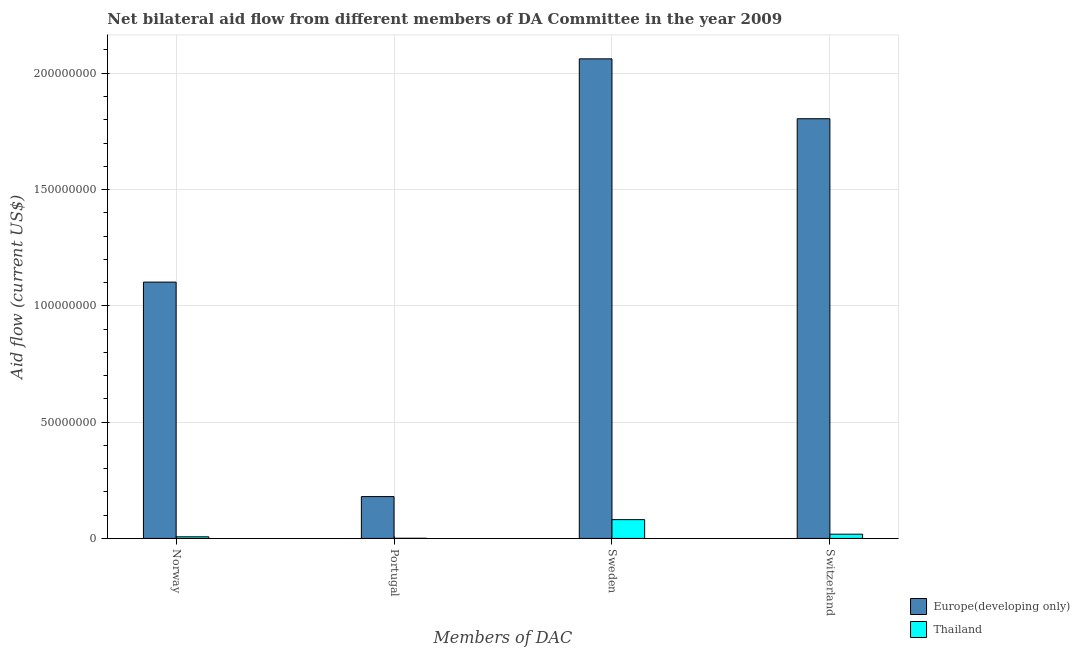Are the number of bars per tick equal to the number of legend labels?
Ensure brevity in your answer.  Yes. How many bars are there on the 4th tick from the left?
Your answer should be very brief. 2. How many bars are there on the 2nd tick from the right?
Your answer should be compact. 2. What is the amount of aid given by switzerland in Europe(developing only)?
Offer a very short reply. 1.80e+08. Across all countries, what is the maximum amount of aid given by portugal?
Ensure brevity in your answer.  1.80e+07. Across all countries, what is the minimum amount of aid given by switzerland?
Your answer should be very brief. 1.82e+06. In which country was the amount of aid given by portugal maximum?
Offer a terse response. Europe(developing only). In which country was the amount of aid given by sweden minimum?
Provide a succinct answer. Thailand. What is the total amount of aid given by sweden in the graph?
Provide a succinct answer. 2.14e+08. What is the difference between the amount of aid given by sweden in Thailand and that in Europe(developing only)?
Your response must be concise. -1.98e+08. What is the difference between the amount of aid given by portugal in Europe(developing only) and the amount of aid given by sweden in Thailand?
Make the answer very short. 9.91e+06. What is the average amount of aid given by switzerland per country?
Make the answer very short. 9.11e+07. What is the difference between the amount of aid given by switzerland and amount of aid given by portugal in Thailand?
Offer a terse response. 1.75e+06. In how many countries, is the amount of aid given by norway greater than 10000000 US$?
Offer a very short reply. 1. What is the ratio of the amount of aid given by switzerland in Thailand to that in Europe(developing only)?
Keep it short and to the point. 0.01. Is the difference between the amount of aid given by norway in Thailand and Europe(developing only) greater than the difference between the amount of aid given by switzerland in Thailand and Europe(developing only)?
Your response must be concise. Yes. What is the difference between the highest and the second highest amount of aid given by norway?
Make the answer very short. 1.10e+08. What is the difference between the highest and the lowest amount of aid given by switzerland?
Your answer should be very brief. 1.79e+08. Is the sum of the amount of aid given by portugal in Europe(developing only) and Thailand greater than the maximum amount of aid given by norway across all countries?
Offer a very short reply. No. Is it the case that in every country, the sum of the amount of aid given by sweden and amount of aid given by norway is greater than the sum of amount of aid given by portugal and amount of aid given by switzerland?
Your answer should be very brief. No. What does the 2nd bar from the left in Sweden represents?
Provide a succinct answer. Thailand. What does the 1st bar from the right in Portugal represents?
Your response must be concise. Thailand. How many bars are there?
Keep it short and to the point. 8. What is the difference between two consecutive major ticks on the Y-axis?
Offer a very short reply. 5.00e+07. Are the values on the major ticks of Y-axis written in scientific E-notation?
Provide a short and direct response. No. How are the legend labels stacked?
Your answer should be very brief. Vertical. What is the title of the graph?
Keep it short and to the point. Net bilateral aid flow from different members of DA Committee in the year 2009. What is the label or title of the X-axis?
Your response must be concise. Members of DAC. What is the label or title of the Y-axis?
Offer a terse response. Aid flow (current US$). What is the Aid flow (current US$) in Europe(developing only) in Norway?
Offer a very short reply. 1.10e+08. What is the Aid flow (current US$) in Europe(developing only) in Portugal?
Ensure brevity in your answer.  1.80e+07. What is the Aid flow (current US$) of Thailand in Portugal?
Offer a terse response. 7.00e+04. What is the Aid flow (current US$) in Europe(developing only) in Sweden?
Offer a terse response. 2.06e+08. What is the Aid flow (current US$) of Thailand in Sweden?
Your answer should be compact. 8.08e+06. What is the Aid flow (current US$) in Europe(developing only) in Switzerland?
Provide a short and direct response. 1.80e+08. What is the Aid flow (current US$) of Thailand in Switzerland?
Your answer should be compact. 1.82e+06. Across all Members of DAC, what is the maximum Aid flow (current US$) of Europe(developing only)?
Offer a terse response. 2.06e+08. Across all Members of DAC, what is the maximum Aid flow (current US$) of Thailand?
Give a very brief answer. 8.08e+06. Across all Members of DAC, what is the minimum Aid flow (current US$) in Europe(developing only)?
Offer a very short reply. 1.80e+07. Across all Members of DAC, what is the minimum Aid flow (current US$) in Thailand?
Ensure brevity in your answer.  7.00e+04. What is the total Aid flow (current US$) of Europe(developing only) in the graph?
Offer a terse response. 5.15e+08. What is the total Aid flow (current US$) in Thailand in the graph?
Give a very brief answer. 1.07e+07. What is the difference between the Aid flow (current US$) in Europe(developing only) in Norway and that in Portugal?
Your answer should be compact. 9.22e+07. What is the difference between the Aid flow (current US$) in Thailand in Norway and that in Portugal?
Your response must be concise. 6.30e+05. What is the difference between the Aid flow (current US$) in Europe(developing only) in Norway and that in Sweden?
Offer a terse response. -9.60e+07. What is the difference between the Aid flow (current US$) of Thailand in Norway and that in Sweden?
Your answer should be very brief. -7.38e+06. What is the difference between the Aid flow (current US$) in Europe(developing only) in Norway and that in Switzerland?
Give a very brief answer. -7.02e+07. What is the difference between the Aid flow (current US$) in Thailand in Norway and that in Switzerland?
Offer a terse response. -1.12e+06. What is the difference between the Aid flow (current US$) of Europe(developing only) in Portugal and that in Sweden?
Provide a succinct answer. -1.88e+08. What is the difference between the Aid flow (current US$) in Thailand in Portugal and that in Sweden?
Provide a succinct answer. -8.01e+06. What is the difference between the Aid flow (current US$) in Europe(developing only) in Portugal and that in Switzerland?
Give a very brief answer. -1.62e+08. What is the difference between the Aid flow (current US$) of Thailand in Portugal and that in Switzerland?
Your answer should be very brief. -1.75e+06. What is the difference between the Aid flow (current US$) of Europe(developing only) in Sweden and that in Switzerland?
Offer a very short reply. 2.57e+07. What is the difference between the Aid flow (current US$) of Thailand in Sweden and that in Switzerland?
Make the answer very short. 6.26e+06. What is the difference between the Aid flow (current US$) in Europe(developing only) in Norway and the Aid flow (current US$) in Thailand in Portugal?
Keep it short and to the point. 1.10e+08. What is the difference between the Aid flow (current US$) in Europe(developing only) in Norway and the Aid flow (current US$) in Thailand in Sweden?
Give a very brief answer. 1.02e+08. What is the difference between the Aid flow (current US$) of Europe(developing only) in Norway and the Aid flow (current US$) of Thailand in Switzerland?
Offer a very short reply. 1.08e+08. What is the difference between the Aid flow (current US$) of Europe(developing only) in Portugal and the Aid flow (current US$) of Thailand in Sweden?
Your response must be concise. 9.91e+06. What is the difference between the Aid flow (current US$) of Europe(developing only) in Portugal and the Aid flow (current US$) of Thailand in Switzerland?
Your answer should be compact. 1.62e+07. What is the difference between the Aid flow (current US$) in Europe(developing only) in Sweden and the Aid flow (current US$) in Thailand in Switzerland?
Your answer should be very brief. 2.04e+08. What is the average Aid flow (current US$) in Europe(developing only) per Members of DAC?
Keep it short and to the point. 1.29e+08. What is the average Aid flow (current US$) of Thailand per Members of DAC?
Give a very brief answer. 2.67e+06. What is the difference between the Aid flow (current US$) in Europe(developing only) and Aid flow (current US$) in Thailand in Norway?
Offer a terse response. 1.10e+08. What is the difference between the Aid flow (current US$) of Europe(developing only) and Aid flow (current US$) of Thailand in Portugal?
Give a very brief answer. 1.79e+07. What is the difference between the Aid flow (current US$) in Europe(developing only) and Aid flow (current US$) in Thailand in Sweden?
Offer a very short reply. 1.98e+08. What is the difference between the Aid flow (current US$) of Europe(developing only) and Aid flow (current US$) of Thailand in Switzerland?
Your response must be concise. 1.79e+08. What is the ratio of the Aid flow (current US$) in Europe(developing only) in Norway to that in Portugal?
Your answer should be compact. 6.13. What is the ratio of the Aid flow (current US$) of Europe(developing only) in Norway to that in Sweden?
Provide a short and direct response. 0.53. What is the ratio of the Aid flow (current US$) of Thailand in Norway to that in Sweden?
Provide a succinct answer. 0.09. What is the ratio of the Aid flow (current US$) of Europe(developing only) in Norway to that in Switzerland?
Offer a very short reply. 0.61. What is the ratio of the Aid flow (current US$) in Thailand in Norway to that in Switzerland?
Keep it short and to the point. 0.38. What is the ratio of the Aid flow (current US$) in Europe(developing only) in Portugal to that in Sweden?
Your response must be concise. 0.09. What is the ratio of the Aid flow (current US$) of Thailand in Portugal to that in Sweden?
Your response must be concise. 0.01. What is the ratio of the Aid flow (current US$) in Europe(developing only) in Portugal to that in Switzerland?
Provide a succinct answer. 0.1. What is the ratio of the Aid flow (current US$) in Thailand in Portugal to that in Switzerland?
Your answer should be very brief. 0.04. What is the ratio of the Aid flow (current US$) in Europe(developing only) in Sweden to that in Switzerland?
Your answer should be very brief. 1.14. What is the ratio of the Aid flow (current US$) in Thailand in Sweden to that in Switzerland?
Keep it short and to the point. 4.44. What is the difference between the highest and the second highest Aid flow (current US$) in Europe(developing only)?
Offer a very short reply. 2.57e+07. What is the difference between the highest and the second highest Aid flow (current US$) of Thailand?
Offer a very short reply. 6.26e+06. What is the difference between the highest and the lowest Aid flow (current US$) of Europe(developing only)?
Offer a terse response. 1.88e+08. What is the difference between the highest and the lowest Aid flow (current US$) of Thailand?
Provide a succinct answer. 8.01e+06. 